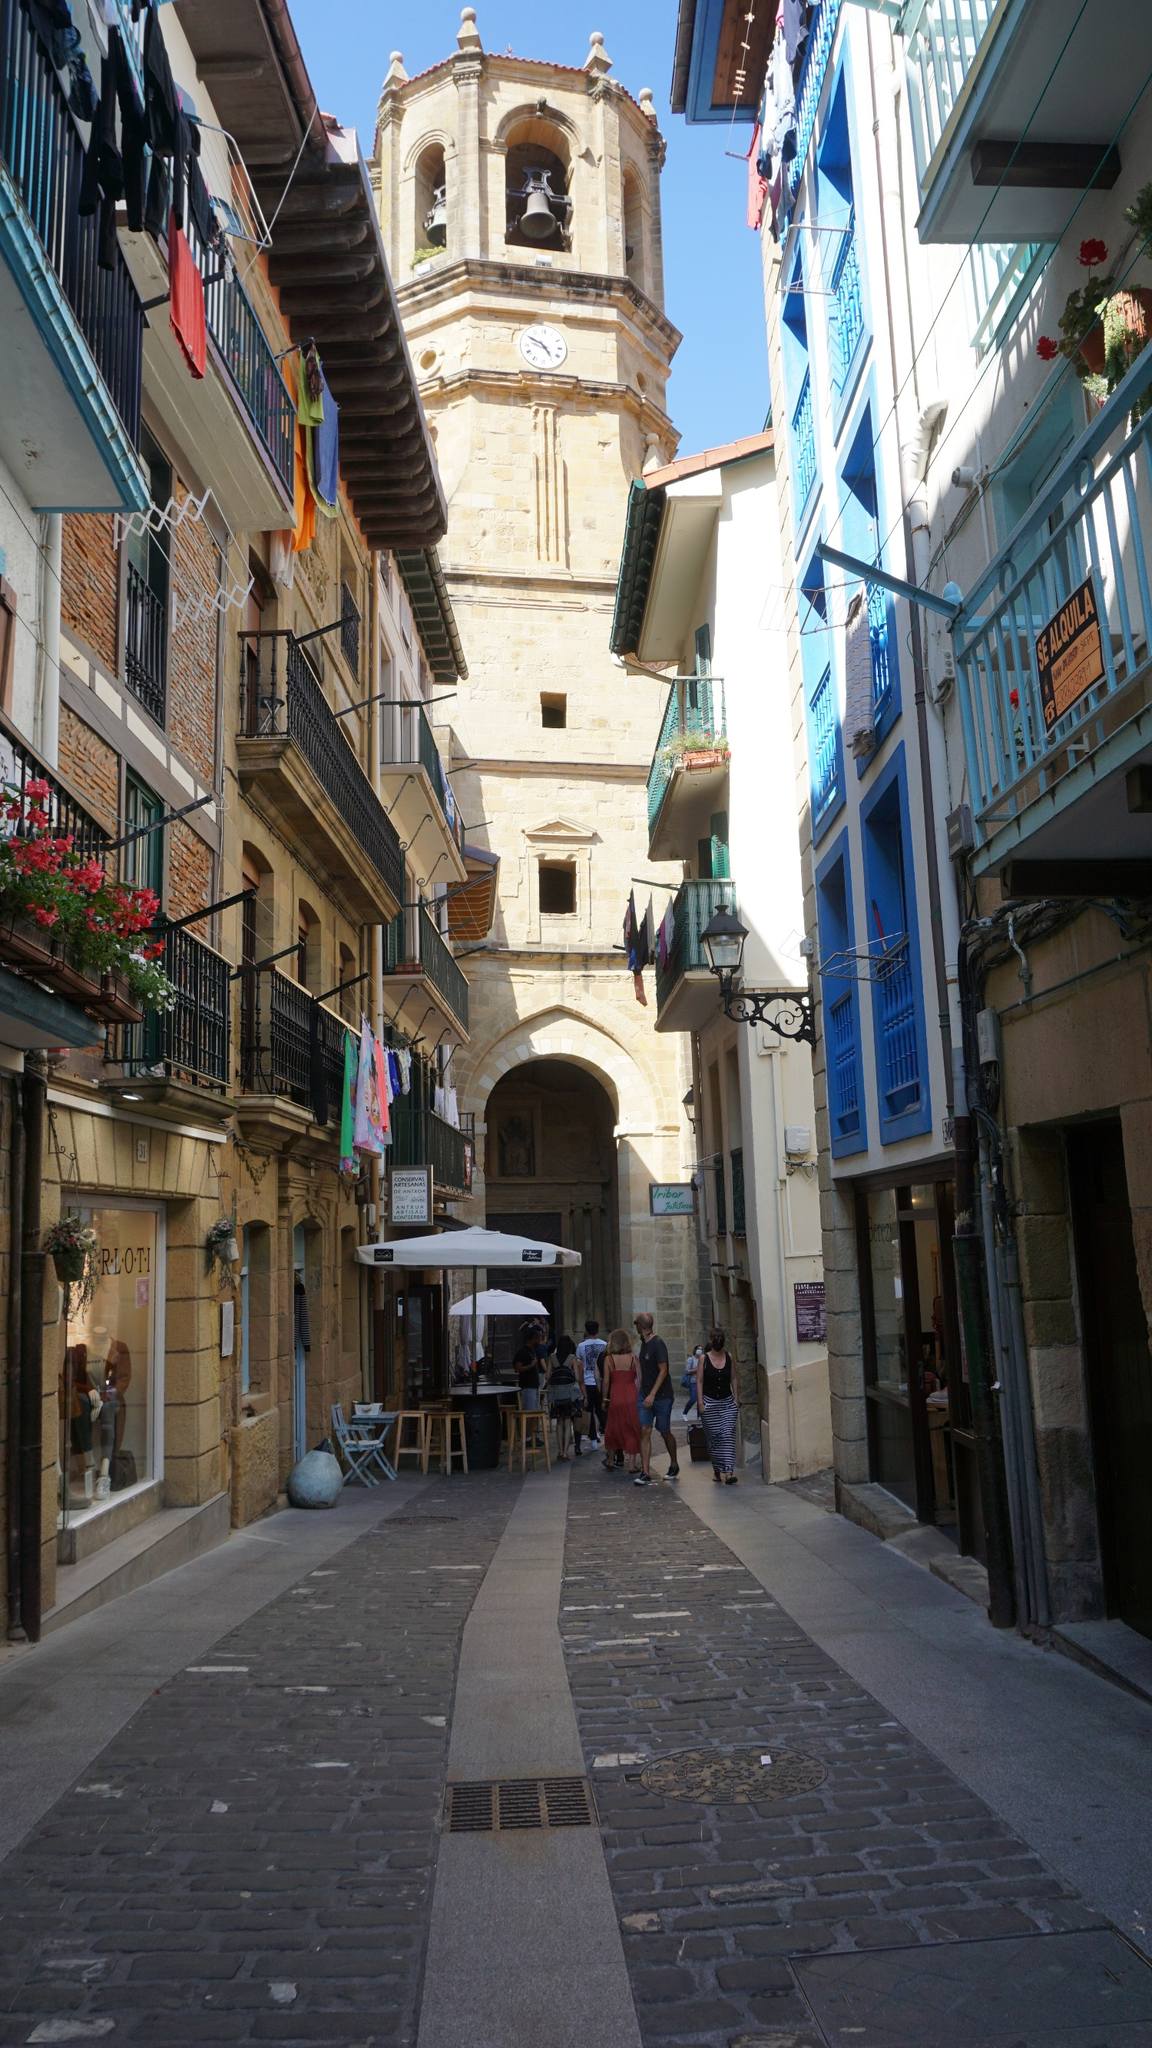What is this photo about? This photo depicts a captivating scene from a quaint European town, showcasing traditional architecture and urban life. The narrow, cobblestone alley, bordered by multi-storied buildings adorned with colorful facades and wrought-iron balconies teeming with flowers, exudes the charm of old-world Europe. Dominating the scene is a towering belfry with a visible clock, suggesting the central role of timekeeping and community gatherings in this town. This architectural marvel not only punctuates the skyline but also serves as a historical beacon for residents and visitors alike. This picture, through its vibrant details and composition, invites viewers to experience the allure and artistic heritage of a European small-town street scene. 